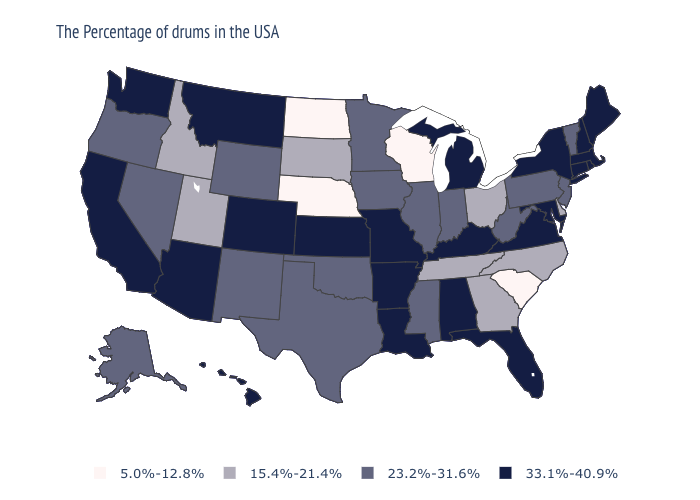Does North Dakota have the lowest value in the USA?
Give a very brief answer. Yes. What is the value of Nevada?
Write a very short answer. 23.2%-31.6%. Which states have the lowest value in the USA?
Short answer required. South Carolina, Wisconsin, Nebraska, North Dakota. What is the lowest value in the West?
Short answer required. 15.4%-21.4%. What is the value of New Jersey?
Keep it brief. 23.2%-31.6%. Name the states that have a value in the range 23.2%-31.6%?
Answer briefly. Vermont, New Jersey, Pennsylvania, West Virginia, Indiana, Illinois, Mississippi, Minnesota, Iowa, Oklahoma, Texas, Wyoming, New Mexico, Nevada, Oregon, Alaska. What is the lowest value in the West?
Concise answer only. 15.4%-21.4%. Does the map have missing data?
Be succinct. No. What is the lowest value in the USA?
Answer briefly. 5.0%-12.8%. What is the highest value in the Northeast ?
Short answer required. 33.1%-40.9%. What is the value of Louisiana?
Concise answer only. 33.1%-40.9%. How many symbols are there in the legend?
Concise answer only. 4. Which states hav the highest value in the MidWest?
Keep it brief. Michigan, Missouri, Kansas. What is the value of Alaska?
Give a very brief answer. 23.2%-31.6%. Name the states that have a value in the range 15.4%-21.4%?
Give a very brief answer. Delaware, North Carolina, Ohio, Georgia, Tennessee, South Dakota, Utah, Idaho. 